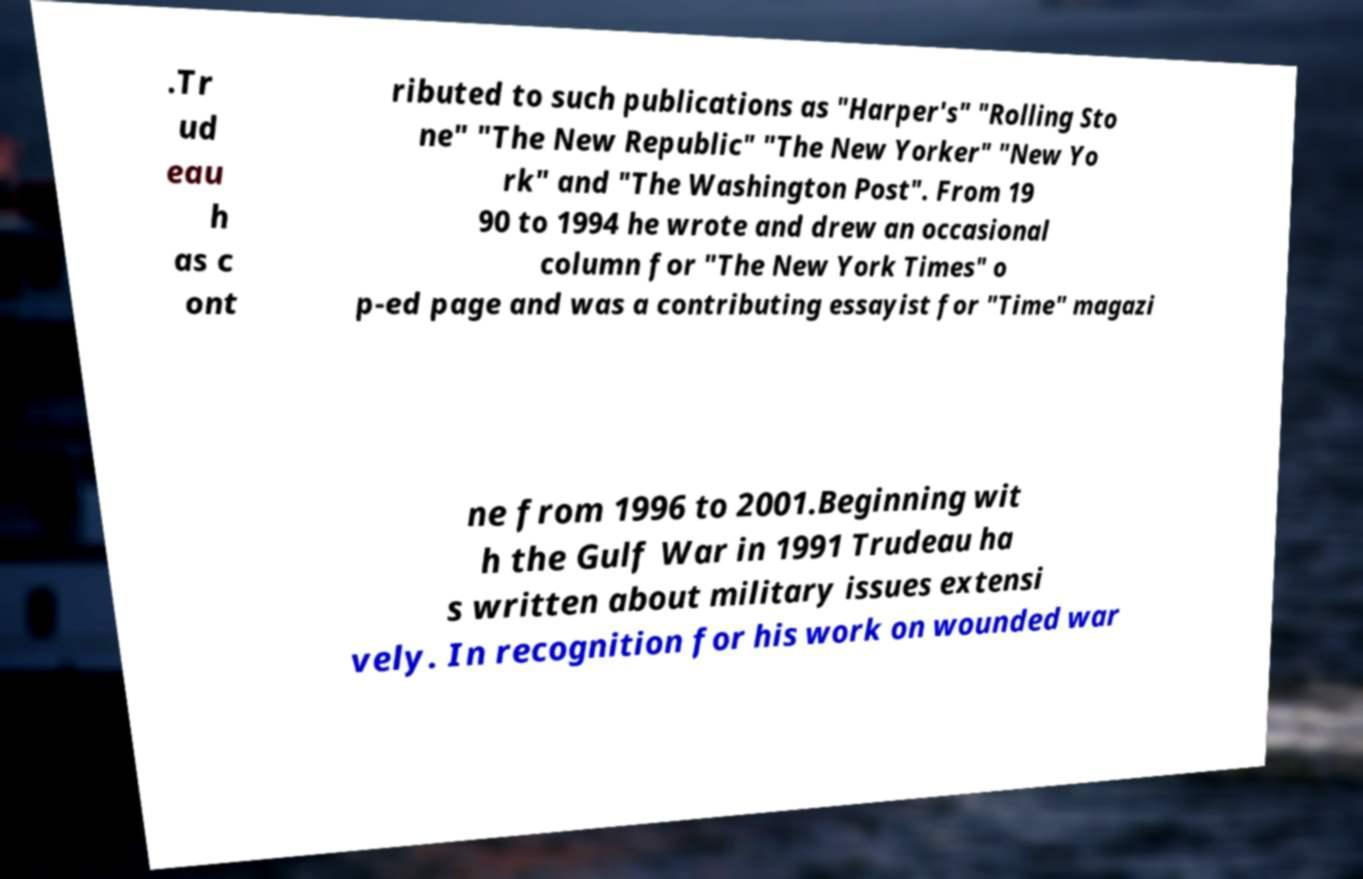What messages or text are displayed in this image? I need them in a readable, typed format. .Tr ud eau h as c ont ributed to such publications as "Harper's" "Rolling Sto ne" "The New Republic" "The New Yorker" "New Yo rk" and "The Washington Post". From 19 90 to 1994 he wrote and drew an occasional column for "The New York Times" o p-ed page and was a contributing essayist for "Time" magazi ne from 1996 to 2001.Beginning wit h the Gulf War in 1991 Trudeau ha s written about military issues extensi vely. In recognition for his work on wounded war 